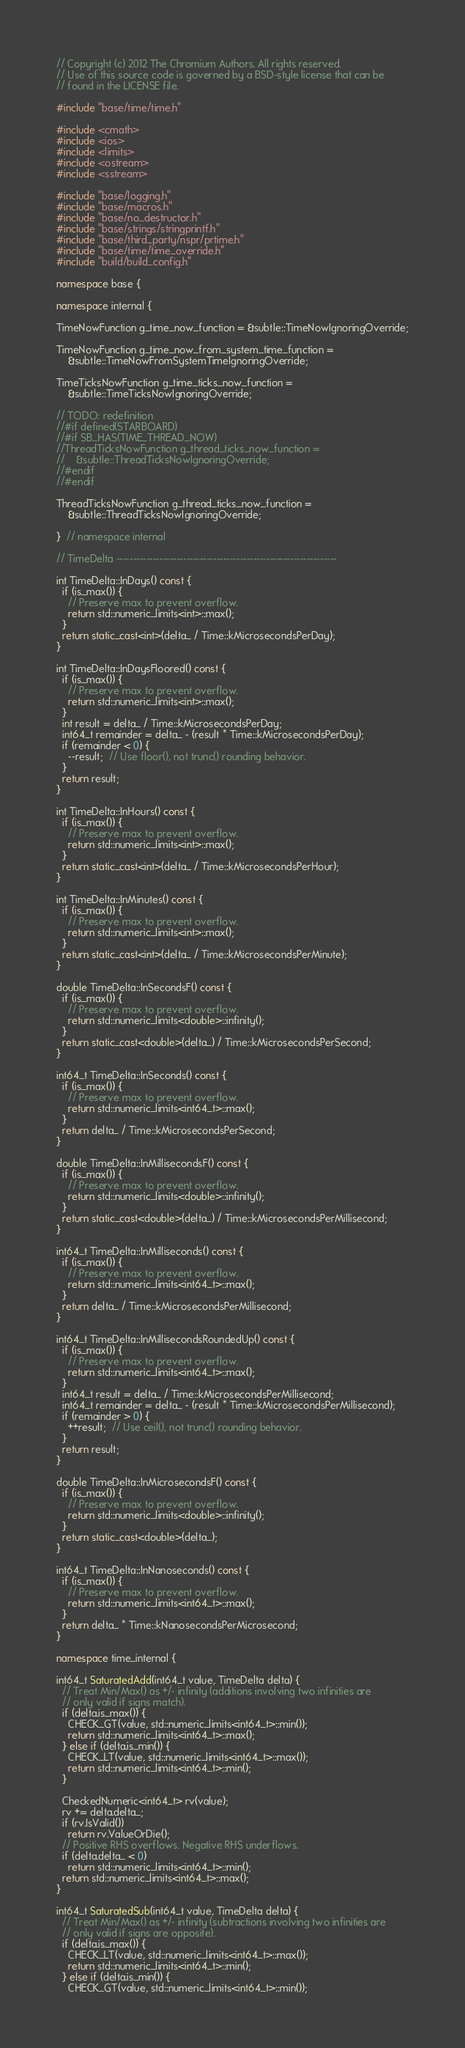Convert code to text. <code><loc_0><loc_0><loc_500><loc_500><_C++_>// Copyright (c) 2012 The Chromium Authors. All rights reserved.
// Use of this source code is governed by a BSD-style license that can be
// found in the LICENSE file.

#include "base/time/time.h"

#include <cmath>
#include <ios>
#include <limits>
#include <ostream>
#include <sstream>

#include "base/logging.h"
#include "base/macros.h"
#include "base/no_destructor.h"
#include "base/strings/stringprintf.h"
#include "base/third_party/nspr/prtime.h"
#include "base/time/time_override.h"
#include "build/build_config.h"

namespace base {

namespace internal {

TimeNowFunction g_time_now_function = &subtle::TimeNowIgnoringOverride;

TimeNowFunction g_time_now_from_system_time_function =
    &subtle::TimeNowFromSystemTimeIgnoringOverride;

TimeTicksNowFunction g_time_ticks_now_function =
    &subtle::TimeTicksNowIgnoringOverride;

// TODO: redefinition
//#if defined(STARBOARD)
//#if SB_HAS(TIME_THREAD_NOW)
//ThreadTicksNowFunction g_thread_ticks_now_function =
//    &subtle::ThreadTicksNowIgnoringOverride;
//#endif
//#endif

ThreadTicksNowFunction g_thread_ticks_now_function =
    &subtle::ThreadTicksNowIgnoringOverride;

}  // namespace internal

// TimeDelta ------------------------------------------------------------------

int TimeDelta::InDays() const {
  if (is_max()) {
    // Preserve max to prevent overflow.
    return std::numeric_limits<int>::max();
  }
  return static_cast<int>(delta_ / Time::kMicrosecondsPerDay);
}

int TimeDelta::InDaysFloored() const {
  if (is_max()) {
    // Preserve max to prevent overflow.
    return std::numeric_limits<int>::max();
  }
  int result = delta_ / Time::kMicrosecondsPerDay;
  int64_t remainder = delta_ - (result * Time::kMicrosecondsPerDay);
  if (remainder < 0) {
    --result;  // Use floor(), not trunc() rounding behavior.
  }
  return result;
}

int TimeDelta::InHours() const {
  if (is_max()) {
    // Preserve max to prevent overflow.
    return std::numeric_limits<int>::max();
  }
  return static_cast<int>(delta_ / Time::kMicrosecondsPerHour);
}

int TimeDelta::InMinutes() const {
  if (is_max()) {
    // Preserve max to prevent overflow.
    return std::numeric_limits<int>::max();
  }
  return static_cast<int>(delta_ / Time::kMicrosecondsPerMinute);
}

double TimeDelta::InSecondsF() const {
  if (is_max()) {
    // Preserve max to prevent overflow.
    return std::numeric_limits<double>::infinity();
  }
  return static_cast<double>(delta_) / Time::kMicrosecondsPerSecond;
}

int64_t TimeDelta::InSeconds() const {
  if (is_max()) {
    // Preserve max to prevent overflow.
    return std::numeric_limits<int64_t>::max();
  }
  return delta_ / Time::kMicrosecondsPerSecond;
}

double TimeDelta::InMillisecondsF() const {
  if (is_max()) {
    // Preserve max to prevent overflow.
    return std::numeric_limits<double>::infinity();
  }
  return static_cast<double>(delta_) / Time::kMicrosecondsPerMillisecond;
}

int64_t TimeDelta::InMilliseconds() const {
  if (is_max()) {
    // Preserve max to prevent overflow.
    return std::numeric_limits<int64_t>::max();
  }
  return delta_ / Time::kMicrosecondsPerMillisecond;
}

int64_t TimeDelta::InMillisecondsRoundedUp() const {
  if (is_max()) {
    // Preserve max to prevent overflow.
    return std::numeric_limits<int64_t>::max();
  }
  int64_t result = delta_ / Time::kMicrosecondsPerMillisecond;
  int64_t remainder = delta_ - (result * Time::kMicrosecondsPerMillisecond);
  if (remainder > 0) {
    ++result;  // Use ceil(), not trunc() rounding behavior.
  }
  return result;
}

double TimeDelta::InMicrosecondsF() const {
  if (is_max()) {
    // Preserve max to prevent overflow.
    return std::numeric_limits<double>::infinity();
  }
  return static_cast<double>(delta_);
}

int64_t TimeDelta::InNanoseconds() const {
  if (is_max()) {
    // Preserve max to prevent overflow.
    return std::numeric_limits<int64_t>::max();
  }
  return delta_ * Time::kNanosecondsPerMicrosecond;
}

namespace time_internal {

int64_t SaturatedAdd(int64_t value, TimeDelta delta) {
  // Treat Min/Max() as +/- infinity (additions involving two infinities are
  // only valid if signs match).
  if (delta.is_max()) {
    CHECK_GT(value, std::numeric_limits<int64_t>::min());
    return std::numeric_limits<int64_t>::max();
  } else if (delta.is_min()) {
    CHECK_LT(value, std::numeric_limits<int64_t>::max());
    return std::numeric_limits<int64_t>::min();
  }

  CheckedNumeric<int64_t> rv(value);
  rv += delta.delta_;
  if (rv.IsValid())
    return rv.ValueOrDie();
  // Positive RHS overflows. Negative RHS underflows.
  if (delta.delta_ < 0)
    return std::numeric_limits<int64_t>::min();
  return std::numeric_limits<int64_t>::max();
}

int64_t SaturatedSub(int64_t value, TimeDelta delta) {
  // Treat Min/Max() as +/- infinity (subtractions involving two infinities are
  // only valid if signs are opposite).
  if (delta.is_max()) {
    CHECK_LT(value, std::numeric_limits<int64_t>::max());
    return std::numeric_limits<int64_t>::min();
  } else if (delta.is_min()) {
    CHECK_GT(value, std::numeric_limits<int64_t>::min());</code> 